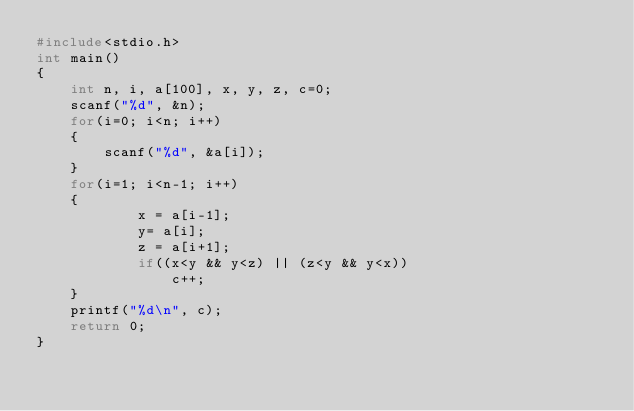<code> <loc_0><loc_0><loc_500><loc_500><_C_>#include<stdio.h>
int main()
{
    int n, i, a[100], x, y, z, c=0;
    scanf("%d", &n);
    for(i=0; i<n; i++)
    {
        scanf("%d", &a[i]);
    }
    for(i=1; i<n-1; i++)
    {
            x = a[i-1];
            y= a[i];
            z = a[i+1];
            if((x<y && y<z) || (z<y && y<x))
                c++;
    }
    printf("%d\n", c);
    return 0;
}</code> 